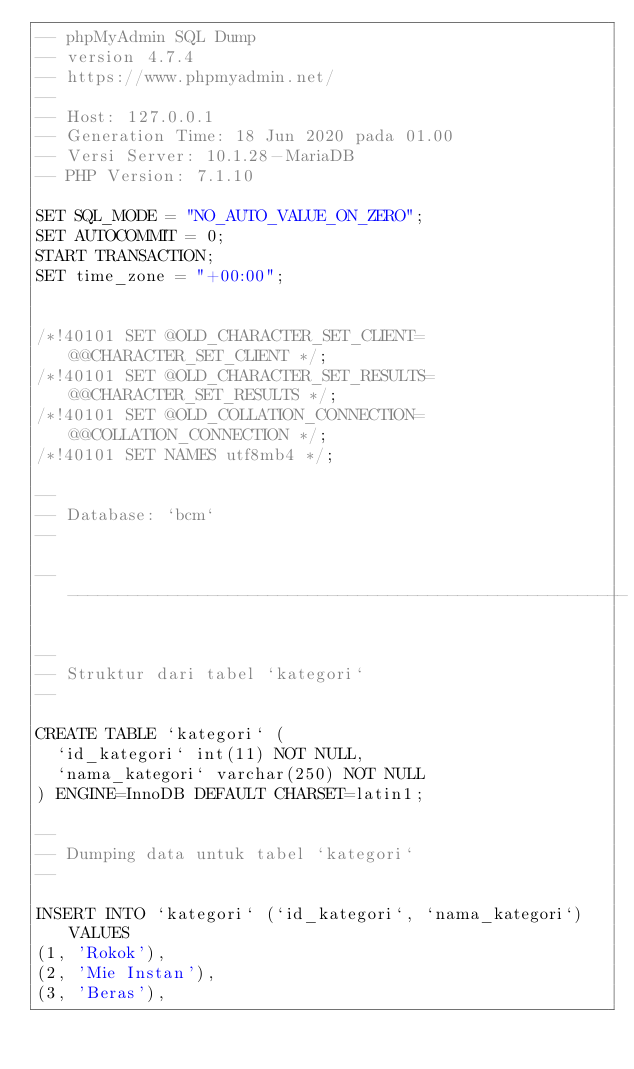<code> <loc_0><loc_0><loc_500><loc_500><_SQL_>-- phpMyAdmin SQL Dump
-- version 4.7.4
-- https://www.phpmyadmin.net/
--
-- Host: 127.0.0.1
-- Generation Time: 18 Jun 2020 pada 01.00
-- Versi Server: 10.1.28-MariaDB
-- PHP Version: 7.1.10

SET SQL_MODE = "NO_AUTO_VALUE_ON_ZERO";
SET AUTOCOMMIT = 0;
START TRANSACTION;
SET time_zone = "+00:00";


/*!40101 SET @OLD_CHARACTER_SET_CLIENT=@@CHARACTER_SET_CLIENT */;
/*!40101 SET @OLD_CHARACTER_SET_RESULTS=@@CHARACTER_SET_RESULTS */;
/*!40101 SET @OLD_COLLATION_CONNECTION=@@COLLATION_CONNECTION */;
/*!40101 SET NAMES utf8mb4 */;

--
-- Database: `bcm`
--

-- --------------------------------------------------------

--
-- Struktur dari tabel `kategori`
--

CREATE TABLE `kategori` (
  `id_kategori` int(11) NOT NULL,
  `nama_kategori` varchar(250) NOT NULL
) ENGINE=InnoDB DEFAULT CHARSET=latin1;

--
-- Dumping data untuk tabel `kategori`
--

INSERT INTO `kategori` (`id_kategori`, `nama_kategori`) VALUES
(1, 'Rokok'),
(2, 'Mie Instan'),
(3, 'Beras'),</code> 